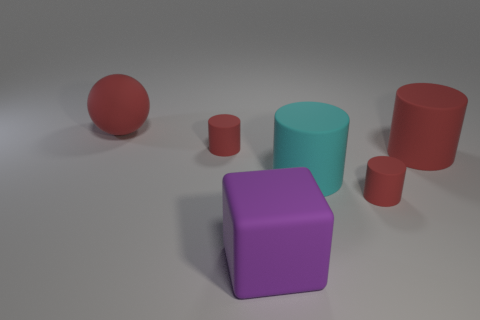How do the colors of the objects contribute to the overall composition? The contrasting colors of the objects—red, purple, and teal—create a vibrant but balanced composition. The distribution of colors is even, with no single hue dominating the scene. Do the colors have any symbolic meaning? In static images like this without additional context, the colors themselves do not necessarily carry symbolic meaning. However, red can often represent passion or energy, purple can symbolize luxury or creativity, and teal might be associated with calmness or sophistication. 